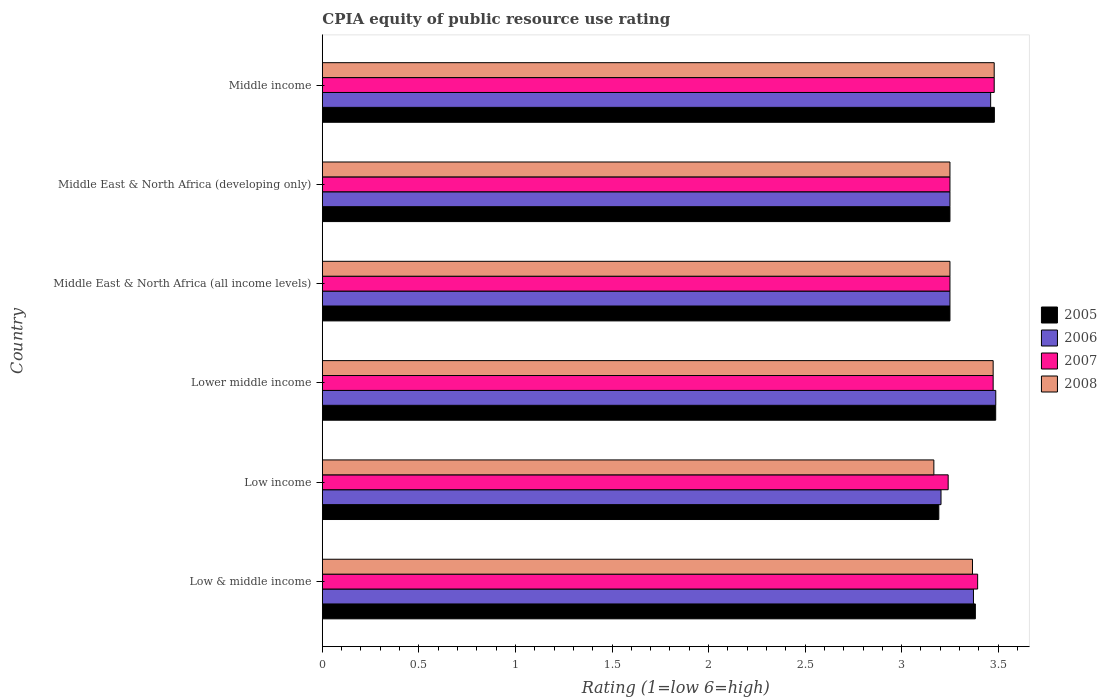How many groups of bars are there?
Give a very brief answer. 6. Are the number of bars on each tick of the Y-axis equal?
Ensure brevity in your answer.  Yes. What is the label of the 4th group of bars from the top?
Provide a short and direct response. Lower middle income. In how many cases, is the number of bars for a given country not equal to the number of legend labels?
Give a very brief answer. 0. Across all countries, what is the maximum CPIA rating in 2008?
Provide a succinct answer. 3.48. Across all countries, what is the minimum CPIA rating in 2006?
Make the answer very short. 3.2. In which country was the CPIA rating in 2006 maximum?
Your answer should be compact. Lower middle income. What is the total CPIA rating in 2008 in the graph?
Provide a short and direct response. 19.99. What is the difference between the CPIA rating in 2005 in Low & middle income and that in Middle East & North Africa (developing only)?
Keep it short and to the point. 0.13. What is the difference between the CPIA rating in 2005 in Middle income and the CPIA rating in 2007 in Low income?
Your answer should be very brief. 0.24. What is the average CPIA rating in 2008 per country?
Make the answer very short. 3.33. What is the difference between the CPIA rating in 2005 and CPIA rating in 2007 in Middle income?
Keep it short and to the point. 0. In how many countries, is the CPIA rating in 2006 greater than 3 ?
Make the answer very short. 6. What is the ratio of the CPIA rating in 2006 in Lower middle income to that in Middle East & North Africa (all income levels)?
Offer a very short reply. 1.07. What is the difference between the highest and the second highest CPIA rating in 2006?
Ensure brevity in your answer.  0.03. What is the difference between the highest and the lowest CPIA rating in 2007?
Your answer should be very brief. 0.24. In how many countries, is the CPIA rating in 2008 greater than the average CPIA rating in 2008 taken over all countries?
Make the answer very short. 3. Is it the case that in every country, the sum of the CPIA rating in 2008 and CPIA rating in 2005 is greater than the sum of CPIA rating in 2007 and CPIA rating in 2006?
Offer a very short reply. No. Is it the case that in every country, the sum of the CPIA rating in 2005 and CPIA rating in 2006 is greater than the CPIA rating in 2008?
Offer a terse response. Yes. Are all the bars in the graph horizontal?
Ensure brevity in your answer.  Yes. Does the graph contain grids?
Keep it short and to the point. No. Where does the legend appear in the graph?
Provide a short and direct response. Center right. How many legend labels are there?
Offer a terse response. 4. What is the title of the graph?
Offer a very short reply. CPIA equity of public resource use rating. What is the label or title of the Y-axis?
Your answer should be compact. Country. What is the Rating (1=low 6=high) of 2005 in Low & middle income?
Your answer should be compact. 3.38. What is the Rating (1=low 6=high) in 2006 in Low & middle income?
Keep it short and to the point. 3.37. What is the Rating (1=low 6=high) in 2007 in Low & middle income?
Ensure brevity in your answer.  3.39. What is the Rating (1=low 6=high) of 2008 in Low & middle income?
Offer a terse response. 3.37. What is the Rating (1=low 6=high) of 2005 in Low income?
Your answer should be compact. 3.19. What is the Rating (1=low 6=high) in 2006 in Low income?
Your answer should be very brief. 3.2. What is the Rating (1=low 6=high) in 2007 in Low income?
Ensure brevity in your answer.  3.24. What is the Rating (1=low 6=high) in 2008 in Low income?
Provide a short and direct response. 3.17. What is the Rating (1=low 6=high) in 2005 in Lower middle income?
Ensure brevity in your answer.  3.49. What is the Rating (1=low 6=high) of 2006 in Lower middle income?
Your answer should be compact. 3.49. What is the Rating (1=low 6=high) in 2007 in Lower middle income?
Offer a terse response. 3.47. What is the Rating (1=low 6=high) in 2008 in Lower middle income?
Offer a terse response. 3.47. What is the Rating (1=low 6=high) of 2005 in Middle East & North Africa (all income levels)?
Ensure brevity in your answer.  3.25. What is the Rating (1=low 6=high) in 2006 in Middle East & North Africa (developing only)?
Offer a terse response. 3.25. What is the Rating (1=low 6=high) of 2007 in Middle East & North Africa (developing only)?
Provide a succinct answer. 3.25. What is the Rating (1=low 6=high) in 2008 in Middle East & North Africa (developing only)?
Provide a succinct answer. 3.25. What is the Rating (1=low 6=high) in 2005 in Middle income?
Provide a succinct answer. 3.48. What is the Rating (1=low 6=high) in 2006 in Middle income?
Offer a terse response. 3.46. What is the Rating (1=low 6=high) in 2007 in Middle income?
Offer a terse response. 3.48. What is the Rating (1=low 6=high) in 2008 in Middle income?
Keep it short and to the point. 3.48. Across all countries, what is the maximum Rating (1=low 6=high) in 2005?
Your answer should be very brief. 3.49. Across all countries, what is the maximum Rating (1=low 6=high) in 2006?
Provide a succinct answer. 3.49. Across all countries, what is the maximum Rating (1=low 6=high) of 2007?
Give a very brief answer. 3.48. Across all countries, what is the maximum Rating (1=low 6=high) of 2008?
Offer a terse response. 3.48. Across all countries, what is the minimum Rating (1=low 6=high) of 2005?
Provide a short and direct response. 3.19. Across all countries, what is the minimum Rating (1=low 6=high) in 2006?
Provide a succinct answer. 3.2. Across all countries, what is the minimum Rating (1=low 6=high) in 2007?
Keep it short and to the point. 3.24. Across all countries, what is the minimum Rating (1=low 6=high) in 2008?
Keep it short and to the point. 3.17. What is the total Rating (1=low 6=high) of 2005 in the graph?
Offer a terse response. 20.04. What is the total Rating (1=low 6=high) of 2006 in the graph?
Provide a succinct answer. 20.02. What is the total Rating (1=low 6=high) in 2007 in the graph?
Your response must be concise. 20.09. What is the total Rating (1=low 6=high) of 2008 in the graph?
Offer a very short reply. 19.99. What is the difference between the Rating (1=low 6=high) of 2005 in Low & middle income and that in Low income?
Your answer should be compact. 0.19. What is the difference between the Rating (1=low 6=high) in 2006 in Low & middle income and that in Low income?
Provide a succinct answer. 0.17. What is the difference between the Rating (1=low 6=high) of 2007 in Low & middle income and that in Low income?
Ensure brevity in your answer.  0.15. What is the difference between the Rating (1=low 6=high) in 2005 in Low & middle income and that in Lower middle income?
Your response must be concise. -0.11. What is the difference between the Rating (1=low 6=high) of 2006 in Low & middle income and that in Lower middle income?
Offer a terse response. -0.12. What is the difference between the Rating (1=low 6=high) in 2007 in Low & middle income and that in Lower middle income?
Your response must be concise. -0.08. What is the difference between the Rating (1=low 6=high) in 2008 in Low & middle income and that in Lower middle income?
Give a very brief answer. -0.11. What is the difference between the Rating (1=low 6=high) of 2005 in Low & middle income and that in Middle East & North Africa (all income levels)?
Ensure brevity in your answer.  0.13. What is the difference between the Rating (1=low 6=high) in 2006 in Low & middle income and that in Middle East & North Africa (all income levels)?
Your response must be concise. 0.12. What is the difference between the Rating (1=low 6=high) of 2007 in Low & middle income and that in Middle East & North Africa (all income levels)?
Give a very brief answer. 0.14. What is the difference between the Rating (1=low 6=high) of 2008 in Low & middle income and that in Middle East & North Africa (all income levels)?
Provide a short and direct response. 0.12. What is the difference between the Rating (1=low 6=high) in 2005 in Low & middle income and that in Middle East & North Africa (developing only)?
Make the answer very short. 0.13. What is the difference between the Rating (1=low 6=high) of 2006 in Low & middle income and that in Middle East & North Africa (developing only)?
Ensure brevity in your answer.  0.12. What is the difference between the Rating (1=low 6=high) of 2007 in Low & middle income and that in Middle East & North Africa (developing only)?
Provide a short and direct response. 0.14. What is the difference between the Rating (1=low 6=high) in 2008 in Low & middle income and that in Middle East & North Africa (developing only)?
Your response must be concise. 0.12. What is the difference between the Rating (1=low 6=high) of 2005 in Low & middle income and that in Middle income?
Your answer should be very brief. -0.1. What is the difference between the Rating (1=low 6=high) of 2006 in Low & middle income and that in Middle income?
Make the answer very short. -0.09. What is the difference between the Rating (1=low 6=high) in 2007 in Low & middle income and that in Middle income?
Ensure brevity in your answer.  -0.09. What is the difference between the Rating (1=low 6=high) of 2008 in Low & middle income and that in Middle income?
Make the answer very short. -0.11. What is the difference between the Rating (1=low 6=high) in 2005 in Low income and that in Lower middle income?
Offer a terse response. -0.29. What is the difference between the Rating (1=low 6=high) in 2006 in Low income and that in Lower middle income?
Provide a succinct answer. -0.28. What is the difference between the Rating (1=low 6=high) in 2007 in Low income and that in Lower middle income?
Provide a succinct answer. -0.23. What is the difference between the Rating (1=low 6=high) of 2008 in Low income and that in Lower middle income?
Provide a short and direct response. -0.31. What is the difference between the Rating (1=low 6=high) in 2005 in Low income and that in Middle East & North Africa (all income levels)?
Your response must be concise. -0.06. What is the difference between the Rating (1=low 6=high) in 2006 in Low income and that in Middle East & North Africa (all income levels)?
Keep it short and to the point. -0.05. What is the difference between the Rating (1=low 6=high) of 2007 in Low income and that in Middle East & North Africa (all income levels)?
Your answer should be very brief. -0.01. What is the difference between the Rating (1=low 6=high) in 2008 in Low income and that in Middle East & North Africa (all income levels)?
Ensure brevity in your answer.  -0.08. What is the difference between the Rating (1=low 6=high) in 2005 in Low income and that in Middle East & North Africa (developing only)?
Provide a succinct answer. -0.06. What is the difference between the Rating (1=low 6=high) in 2006 in Low income and that in Middle East & North Africa (developing only)?
Give a very brief answer. -0.05. What is the difference between the Rating (1=low 6=high) in 2007 in Low income and that in Middle East & North Africa (developing only)?
Ensure brevity in your answer.  -0.01. What is the difference between the Rating (1=low 6=high) in 2008 in Low income and that in Middle East & North Africa (developing only)?
Make the answer very short. -0.08. What is the difference between the Rating (1=low 6=high) in 2005 in Low income and that in Middle income?
Your response must be concise. -0.29. What is the difference between the Rating (1=low 6=high) in 2006 in Low income and that in Middle income?
Keep it short and to the point. -0.26. What is the difference between the Rating (1=low 6=high) of 2007 in Low income and that in Middle income?
Provide a succinct answer. -0.24. What is the difference between the Rating (1=low 6=high) in 2008 in Low income and that in Middle income?
Provide a succinct answer. -0.31. What is the difference between the Rating (1=low 6=high) of 2005 in Lower middle income and that in Middle East & North Africa (all income levels)?
Provide a succinct answer. 0.24. What is the difference between the Rating (1=low 6=high) in 2006 in Lower middle income and that in Middle East & North Africa (all income levels)?
Your answer should be compact. 0.24. What is the difference between the Rating (1=low 6=high) of 2007 in Lower middle income and that in Middle East & North Africa (all income levels)?
Ensure brevity in your answer.  0.22. What is the difference between the Rating (1=low 6=high) of 2008 in Lower middle income and that in Middle East & North Africa (all income levels)?
Your answer should be compact. 0.22. What is the difference between the Rating (1=low 6=high) of 2005 in Lower middle income and that in Middle East & North Africa (developing only)?
Give a very brief answer. 0.24. What is the difference between the Rating (1=low 6=high) of 2006 in Lower middle income and that in Middle East & North Africa (developing only)?
Keep it short and to the point. 0.24. What is the difference between the Rating (1=low 6=high) in 2007 in Lower middle income and that in Middle East & North Africa (developing only)?
Give a very brief answer. 0.22. What is the difference between the Rating (1=low 6=high) of 2008 in Lower middle income and that in Middle East & North Africa (developing only)?
Offer a terse response. 0.22. What is the difference between the Rating (1=low 6=high) of 2005 in Lower middle income and that in Middle income?
Provide a short and direct response. 0.01. What is the difference between the Rating (1=low 6=high) of 2006 in Lower middle income and that in Middle income?
Give a very brief answer. 0.03. What is the difference between the Rating (1=low 6=high) in 2007 in Lower middle income and that in Middle income?
Ensure brevity in your answer.  -0.01. What is the difference between the Rating (1=low 6=high) of 2008 in Lower middle income and that in Middle income?
Offer a terse response. -0.01. What is the difference between the Rating (1=low 6=high) of 2005 in Middle East & North Africa (all income levels) and that in Middle East & North Africa (developing only)?
Your answer should be compact. 0. What is the difference between the Rating (1=low 6=high) in 2008 in Middle East & North Africa (all income levels) and that in Middle East & North Africa (developing only)?
Your response must be concise. 0. What is the difference between the Rating (1=low 6=high) in 2005 in Middle East & North Africa (all income levels) and that in Middle income?
Ensure brevity in your answer.  -0.23. What is the difference between the Rating (1=low 6=high) in 2006 in Middle East & North Africa (all income levels) and that in Middle income?
Keep it short and to the point. -0.21. What is the difference between the Rating (1=low 6=high) of 2007 in Middle East & North Africa (all income levels) and that in Middle income?
Provide a succinct answer. -0.23. What is the difference between the Rating (1=low 6=high) of 2008 in Middle East & North Africa (all income levels) and that in Middle income?
Your response must be concise. -0.23. What is the difference between the Rating (1=low 6=high) of 2005 in Middle East & North Africa (developing only) and that in Middle income?
Make the answer very short. -0.23. What is the difference between the Rating (1=low 6=high) in 2006 in Middle East & North Africa (developing only) and that in Middle income?
Provide a short and direct response. -0.21. What is the difference between the Rating (1=low 6=high) of 2007 in Middle East & North Africa (developing only) and that in Middle income?
Your answer should be compact. -0.23. What is the difference between the Rating (1=low 6=high) of 2008 in Middle East & North Africa (developing only) and that in Middle income?
Provide a succinct answer. -0.23. What is the difference between the Rating (1=low 6=high) of 2005 in Low & middle income and the Rating (1=low 6=high) of 2006 in Low income?
Make the answer very short. 0.18. What is the difference between the Rating (1=low 6=high) of 2005 in Low & middle income and the Rating (1=low 6=high) of 2007 in Low income?
Ensure brevity in your answer.  0.14. What is the difference between the Rating (1=low 6=high) of 2005 in Low & middle income and the Rating (1=low 6=high) of 2008 in Low income?
Provide a succinct answer. 0.21. What is the difference between the Rating (1=low 6=high) in 2006 in Low & middle income and the Rating (1=low 6=high) in 2007 in Low income?
Provide a short and direct response. 0.13. What is the difference between the Rating (1=low 6=high) in 2006 in Low & middle income and the Rating (1=low 6=high) in 2008 in Low income?
Provide a succinct answer. 0.21. What is the difference between the Rating (1=low 6=high) in 2007 in Low & middle income and the Rating (1=low 6=high) in 2008 in Low income?
Provide a short and direct response. 0.23. What is the difference between the Rating (1=low 6=high) in 2005 in Low & middle income and the Rating (1=low 6=high) in 2006 in Lower middle income?
Your response must be concise. -0.11. What is the difference between the Rating (1=low 6=high) in 2005 in Low & middle income and the Rating (1=low 6=high) in 2007 in Lower middle income?
Ensure brevity in your answer.  -0.09. What is the difference between the Rating (1=low 6=high) of 2005 in Low & middle income and the Rating (1=low 6=high) of 2008 in Lower middle income?
Provide a short and direct response. -0.09. What is the difference between the Rating (1=low 6=high) in 2006 in Low & middle income and the Rating (1=low 6=high) in 2007 in Lower middle income?
Your answer should be compact. -0.1. What is the difference between the Rating (1=low 6=high) in 2006 in Low & middle income and the Rating (1=low 6=high) in 2008 in Lower middle income?
Your answer should be compact. -0.1. What is the difference between the Rating (1=low 6=high) in 2007 in Low & middle income and the Rating (1=low 6=high) in 2008 in Lower middle income?
Keep it short and to the point. -0.08. What is the difference between the Rating (1=low 6=high) in 2005 in Low & middle income and the Rating (1=low 6=high) in 2006 in Middle East & North Africa (all income levels)?
Offer a terse response. 0.13. What is the difference between the Rating (1=low 6=high) of 2005 in Low & middle income and the Rating (1=low 6=high) of 2007 in Middle East & North Africa (all income levels)?
Ensure brevity in your answer.  0.13. What is the difference between the Rating (1=low 6=high) in 2005 in Low & middle income and the Rating (1=low 6=high) in 2008 in Middle East & North Africa (all income levels)?
Offer a very short reply. 0.13. What is the difference between the Rating (1=low 6=high) in 2006 in Low & middle income and the Rating (1=low 6=high) in 2007 in Middle East & North Africa (all income levels)?
Your response must be concise. 0.12. What is the difference between the Rating (1=low 6=high) in 2006 in Low & middle income and the Rating (1=low 6=high) in 2008 in Middle East & North Africa (all income levels)?
Offer a terse response. 0.12. What is the difference between the Rating (1=low 6=high) in 2007 in Low & middle income and the Rating (1=low 6=high) in 2008 in Middle East & North Africa (all income levels)?
Give a very brief answer. 0.14. What is the difference between the Rating (1=low 6=high) of 2005 in Low & middle income and the Rating (1=low 6=high) of 2006 in Middle East & North Africa (developing only)?
Ensure brevity in your answer.  0.13. What is the difference between the Rating (1=low 6=high) of 2005 in Low & middle income and the Rating (1=low 6=high) of 2007 in Middle East & North Africa (developing only)?
Your response must be concise. 0.13. What is the difference between the Rating (1=low 6=high) in 2005 in Low & middle income and the Rating (1=low 6=high) in 2008 in Middle East & North Africa (developing only)?
Offer a terse response. 0.13. What is the difference between the Rating (1=low 6=high) of 2006 in Low & middle income and the Rating (1=low 6=high) of 2007 in Middle East & North Africa (developing only)?
Your answer should be compact. 0.12. What is the difference between the Rating (1=low 6=high) in 2006 in Low & middle income and the Rating (1=low 6=high) in 2008 in Middle East & North Africa (developing only)?
Your answer should be very brief. 0.12. What is the difference between the Rating (1=low 6=high) of 2007 in Low & middle income and the Rating (1=low 6=high) of 2008 in Middle East & North Africa (developing only)?
Provide a short and direct response. 0.14. What is the difference between the Rating (1=low 6=high) of 2005 in Low & middle income and the Rating (1=low 6=high) of 2006 in Middle income?
Offer a very short reply. -0.08. What is the difference between the Rating (1=low 6=high) in 2005 in Low & middle income and the Rating (1=low 6=high) in 2007 in Middle income?
Keep it short and to the point. -0.1. What is the difference between the Rating (1=low 6=high) in 2005 in Low & middle income and the Rating (1=low 6=high) in 2008 in Middle income?
Offer a very short reply. -0.1. What is the difference between the Rating (1=low 6=high) in 2006 in Low & middle income and the Rating (1=low 6=high) in 2007 in Middle income?
Ensure brevity in your answer.  -0.11. What is the difference between the Rating (1=low 6=high) in 2006 in Low & middle income and the Rating (1=low 6=high) in 2008 in Middle income?
Give a very brief answer. -0.11. What is the difference between the Rating (1=low 6=high) of 2007 in Low & middle income and the Rating (1=low 6=high) of 2008 in Middle income?
Ensure brevity in your answer.  -0.09. What is the difference between the Rating (1=low 6=high) in 2005 in Low income and the Rating (1=low 6=high) in 2006 in Lower middle income?
Provide a succinct answer. -0.29. What is the difference between the Rating (1=low 6=high) in 2005 in Low income and the Rating (1=low 6=high) in 2007 in Lower middle income?
Provide a short and direct response. -0.28. What is the difference between the Rating (1=low 6=high) in 2005 in Low income and the Rating (1=low 6=high) in 2008 in Lower middle income?
Provide a succinct answer. -0.28. What is the difference between the Rating (1=low 6=high) in 2006 in Low income and the Rating (1=low 6=high) in 2007 in Lower middle income?
Provide a succinct answer. -0.27. What is the difference between the Rating (1=low 6=high) of 2006 in Low income and the Rating (1=low 6=high) of 2008 in Lower middle income?
Give a very brief answer. -0.27. What is the difference between the Rating (1=low 6=high) in 2007 in Low income and the Rating (1=low 6=high) in 2008 in Lower middle income?
Provide a succinct answer. -0.23. What is the difference between the Rating (1=low 6=high) of 2005 in Low income and the Rating (1=low 6=high) of 2006 in Middle East & North Africa (all income levels)?
Ensure brevity in your answer.  -0.06. What is the difference between the Rating (1=low 6=high) in 2005 in Low income and the Rating (1=low 6=high) in 2007 in Middle East & North Africa (all income levels)?
Offer a very short reply. -0.06. What is the difference between the Rating (1=low 6=high) in 2005 in Low income and the Rating (1=low 6=high) in 2008 in Middle East & North Africa (all income levels)?
Give a very brief answer. -0.06. What is the difference between the Rating (1=low 6=high) in 2006 in Low income and the Rating (1=low 6=high) in 2007 in Middle East & North Africa (all income levels)?
Ensure brevity in your answer.  -0.05. What is the difference between the Rating (1=low 6=high) of 2006 in Low income and the Rating (1=low 6=high) of 2008 in Middle East & North Africa (all income levels)?
Provide a succinct answer. -0.05. What is the difference between the Rating (1=low 6=high) in 2007 in Low income and the Rating (1=low 6=high) in 2008 in Middle East & North Africa (all income levels)?
Your answer should be compact. -0.01. What is the difference between the Rating (1=low 6=high) of 2005 in Low income and the Rating (1=low 6=high) of 2006 in Middle East & North Africa (developing only)?
Provide a short and direct response. -0.06. What is the difference between the Rating (1=low 6=high) in 2005 in Low income and the Rating (1=low 6=high) in 2007 in Middle East & North Africa (developing only)?
Provide a succinct answer. -0.06. What is the difference between the Rating (1=low 6=high) of 2005 in Low income and the Rating (1=low 6=high) of 2008 in Middle East & North Africa (developing only)?
Offer a terse response. -0.06. What is the difference between the Rating (1=low 6=high) of 2006 in Low income and the Rating (1=low 6=high) of 2007 in Middle East & North Africa (developing only)?
Your answer should be compact. -0.05. What is the difference between the Rating (1=low 6=high) of 2006 in Low income and the Rating (1=low 6=high) of 2008 in Middle East & North Africa (developing only)?
Give a very brief answer. -0.05. What is the difference between the Rating (1=low 6=high) of 2007 in Low income and the Rating (1=low 6=high) of 2008 in Middle East & North Africa (developing only)?
Make the answer very short. -0.01. What is the difference between the Rating (1=low 6=high) of 2005 in Low income and the Rating (1=low 6=high) of 2006 in Middle income?
Provide a succinct answer. -0.27. What is the difference between the Rating (1=low 6=high) of 2005 in Low income and the Rating (1=low 6=high) of 2007 in Middle income?
Your response must be concise. -0.29. What is the difference between the Rating (1=low 6=high) in 2005 in Low income and the Rating (1=low 6=high) in 2008 in Middle income?
Your response must be concise. -0.29. What is the difference between the Rating (1=low 6=high) in 2006 in Low income and the Rating (1=low 6=high) in 2007 in Middle income?
Ensure brevity in your answer.  -0.28. What is the difference between the Rating (1=low 6=high) of 2006 in Low income and the Rating (1=low 6=high) of 2008 in Middle income?
Your answer should be very brief. -0.28. What is the difference between the Rating (1=low 6=high) in 2007 in Low income and the Rating (1=low 6=high) in 2008 in Middle income?
Keep it short and to the point. -0.24. What is the difference between the Rating (1=low 6=high) of 2005 in Lower middle income and the Rating (1=low 6=high) of 2006 in Middle East & North Africa (all income levels)?
Ensure brevity in your answer.  0.24. What is the difference between the Rating (1=low 6=high) of 2005 in Lower middle income and the Rating (1=low 6=high) of 2007 in Middle East & North Africa (all income levels)?
Ensure brevity in your answer.  0.24. What is the difference between the Rating (1=low 6=high) in 2005 in Lower middle income and the Rating (1=low 6=high) in 2008 in Middle East & North Africa (all income levels)?
Make the answer very short. 0.24. What is the difference between the Rating (1=low 6=high) in 2006 in Lower middle income and the Rating (1=low 6=high) in 2007 in Middle East & North Africa (all income levels)?
Keep it short and to the point. 0.24. What is the difference between the Rating (1=low 6=high) of 2006 in Lower middle income and the Rating (1=low 6=high) of 2008 in Middle East & North Africa (all income levels)?
Your response must be concise. 0.24. What is the difference between the Rating (1=low 6=high) in 2007 in Lower middle income and the Rating (1=low 6=high) in 2008 in Middle East & North Africa (all income levels)?
Offer a terse response. 0.22. What is the difference between the Rating (1=low 6=high) of 2005 in Lower middle income and the Rating (1=low 6=high) of 2006 in Middle East & North Africa (developing only)?
Ensure brevity in your answer.  0.24. What is the difference between the Rating (1=low 6=high) in 2005 in Lower middle income and the Rating (1=low 6=high) in 2007 in Middle East & North Africa (developing only)?
Your answer should be compact. 0.24. What is the difference between the Rating (1=low 6=high) in 2005 in Lower middle income and the Rating (1=low 6=high) in 2008 in Middle East & North Africa (developing only)?
Ensure brevity in your answer.  0.24. What is the difference between the Rating (1=low 6=high) in 2006 in Lower middle income and the Rating (1=low 6=high) in 2007 in Middle East & North Africa (developing only)?
Ensure brevity in your answer.  0.24. What is the difference between the Rating (1=low 6=high) in 2006 in Lower middle income and the Rating (1=low 6=high) in 2008 in Middle East & North Africa (developing only)?
Your response must be concise. 0.24. What is the difference between the Rating (1=low 6=high) in 2007 in Lower middle income and the Rating (1=low 6=high) in 2008 in Middle East & North Africa (developing only)?
Give a very brief answer. 0.22. What is the difference between the Rating (1=low 6=high) of 2005 in Lower middle income and the Rating (1=low 6=high) of 2006 in Middle income?
Offer a very short reply. 0.03. What is the difference between the Rating (1=low 6=high) of 2005 in Lower middle income and the Rating (1=low 6=high) of 2007 in Middle income?
Your answer should be compact. 0.01. What is the difference between the Rating (1=low 6=high) of 2005 in Lower middle income and the Rating (1=low 6=high) of 2008 in Middle income?
Offer a very short reply. 0.01. What is the difference between the Rating (1=low 6=high) in 2006 in Lower middle income and the Rating (1=low 6=high) in 2007 in Middle income?
Provide a succinct answer. 0.01. What is the difference between the Rating (1=low 6=high) of 2006 in Lower middle income and the Rating (1=low 6=high) of 2008 in Middle income?
Your answer should be very brief. 0.01. What is the difference between the Rating (1=low 6=high) of 2007 in Lower middle income and the Rating (1=low 6=high) of 2008 in Middle income?
Ensure brevity in your answer.  -0.01. What is the difference between the Rating (1=low 6=high) of 2005 in Middle East & North Africa (all income levels) and the Rating (1=low 6=high) of 2006 in Middle East & North Africa (developing only)?
Make the answer very short. 0. What is the difference between the Rating (1=low 6=high) in 2005 in Middle East & North Africa (all income levels) and the Rating (1=low 6=high) in 2007 in Middle East & North Africa (developing only)?
Provide a short and direct response. 0. What is the difference between the Rating (1=low 6=high) of 2005 in Middle East & North Africa (all income levels) and the Rating (1=low 6=high) of 2008 in Middle East & North Africa (developing only)?
Keep it short and to the point. 0. What is the difference between the Rating (1=low 6=high) in 2006 in Middle East & North Africa (all income levels) and the Rating (1=low 6=high) in 2007 in Middle East & North Africa (developing only)?
Offer a terse response. 0. What is the difference between the Rating (1=low 6=high) of 2007 in Middle East & North Africa (all income levels) and the Rating (1=low 6=high) of 2008 in Middle East & North Africa (developing only)?
Keep it short and to the point. 0. What is the difference between the Rating (1=low 6=high) of 2005 in Middle East & North Africa (all income levels) and the Rating (1=low 6=high) of 2006 in Middle income?
Keep it short and to the point. -0.21. What is the difference between the Rating (1=low 6=high) of 2005 in Middle East & North Africa (all income levels) and the Rating (1=low 6=high) of 2007 in Middle income?
Your answer should be compact. -0.23. What is the difference between the Rating (1=low 6=high) in 2005 in Middle East & North Africa (all income levels) and the Rating (1=low 6=high) in 2008 in Middle income?
Your answer should be compact. -0.23. What is the difference between the Rating (1=low 6=high) of 2006 in Middle East & North Africa (all income levels) and the Rating (1=low 6=high) of 2007 in Middle income?
Keep it short and to the point. -0.23. What is the difference between the Rating (1=low 6=high) of 2006 in Middle East & North Africa (all income levels) and the Rating (1=low 6=high) of 2008 in Middle income?
Offer a very short reply. -0.23. What is the difference between the Rating (1=low 6=high) of 2007 in Middle East & North Africa (all income levels) and the Rating (1=low 6=high) of 2008 in Middle income?
Your response must be concise. -0.23. What is the difference between the Rating (1=low 6=high) of 2005 in Middle East & North Africa (developing only) and the Rating (1=low 6=high) of 2006 in Middle income?
Give a very brief answer. -0.21. What is the difference between the Rating (1=low 6=high) in 2005 in Middle East & North Africa (developing only) and the Rating (1=low 6=high) in 2007 in Middle income?
Keep it short and to the point. -0.23. What is the difference between the Rating (1=low 6=high) in 2005 in Middle East & North Africa (developing only) and the Rating (1=low 6=high) in 2008 in Middle income?
Ensure brevity in your answer.  -0.23. What is the difference between the Rating (1=low 6=high) of 2006 in Middle East & North Africa (developing only) and the Rating (1=low 6=high) of 2007 in Middle income?
Your response must be concise. -0.23. What is the difference between the Rating (1=low 6=high) of 2006 in Middle East & North Africa (developing only) and the Rating (1=low 6=high) of 2008 in Middle income?
Your answer should be compact. -0.23. What is the difference between the Rating (1=low 6=high) of 2007 in Middle East & North Africa (developing only) and the Rating (1=low 6=high) of 2008 in Middle income?
Give a very brief answer. -0.23. What is the average Rating (1=low 6=high) in 2005 per country?
Offer a terse response. 3.34. What is the average Rating (1=low 6=high) in 2006 per country?
Provide a succinct answer. 3.34. What is the average Rating (1=low 6=high) in 2007 per country?
Offer a terse response. 3.35. What is the average Rating (1=low 6=high) of 2008 per country?
Provide a short and direct response. 3.33. What is the difference between the Rating (1=low 6=high) in 2005 and Rating (1=low 6=high) in 2006 in Low & middle income?
Your answer should be compact. 0.01. What is the difference between the Rating (1=low 6=high) of 2005 and Rating (1=low 6=high) of 2007 in Low & middle income?
Ensure brevity in your answer.  -0.01. What is the difference between the Rating (1=low 6=high) in 2005 and Rating (1=low 6=high) in 2008 in Low & middle income?
Your response must be concise. 0.01. What is the difference between the Rating (1=low 6=high) of 2006 and Rating (1=low 6=high) of 2007 in Low & middle income?
Your answer should be compact. -0.02. What is the difference between the Rating (1=low 6=high) of 2006 and Rating (1=low 6=high) of 2008 in Low & middle income?
Your answer should be very brief. 0.01. What is the difference between the Rating (1=low 6=high) in 2007 and Rating (1=low 6=high) in 2008 in Low & middle income?
Your answer should be very brief. 0.03. What is the difference between the Rating (1=low 6=high) of 2005 and Rating (1=low 6=high) of 2006 in Low income?
Give a very brief answer. -0.01. What is the difference between the Rating (1=low 6=high) of 2005 and Rating (1=low 6=high) of 2007 in Low income?
Make the answer very short. -0.05. What is the difference between the Rating (1=low 6=high) in 2005 and Rating (1=low 6=high) in 2008 in Low income?
Provide a short and direct response. 0.03. What is the difference between the Rating (1=low 6=high) of 2006 and Rating (1=low 6=high) of 2007 in Low income?
Offer a very short reply. -0.04. What is the difference between the Rating (1=low 6=high) of 2006 and Rating (1=low 6=high) of 2008 in Low income?
Offer a very short reply. 0.04. What is the difference between the Rating (1=low 6=high) in 2007 and Rating (1=low 6=high) in 2008 in Low income?
Make the answer very short. 0.07. What is the difference between the Rating (1=low 6=high) in 2005 and Rating (1=low 6=high) in 2006 in Lower middle income?
Provide a succinct answer. -0. What is the difference between the Rating (1=low 6=high) in 2005 and Rating (1=low 6=high) in 2007 in Lower middle income?
Make the answer very short. 0.01. What is the difference between the Rating (1=low 6=high) of 2005 and Rating (1=low 6=high) of 2008 in Lower middle income?
Keep it short and to the point. 0.01. What is the difference between the Rating (1=low 6=high) of 2006 and Rating (1=low 6=high) of 2007 in Lower middle income?
Your answer should be very brief. 0.01. What is the difference between the Rating (1=low 6=high) of 2006 and Rating (1=low 6=high) of 2008 in Lower middle income?
Your response must be concise. 0.01. What is the difference between the Rating (1=low 6=high) of 2005 and Rating (1=low 6=high) of 2006 in Middle East & North Africa (all income levels)?
Offer a very short reply. 0. What is the difference between the Rating (1=low 6=high) in 2005 and Rating (1=low 6=high) in 2007 in Middle East & North Africa (all income levels)?
Your answer should be very brief. 0. What is the difference between the Rating (1=low 6=high) in 2007 and Rating (1=low 6=high) in 2008 in Middle East & North Africa (all income levels)?
Provide a succinct answer. 0. What is the difference between the Rating (1=low 6=high) in 2005 and Rating (1=low 6=high) in 2007 in Middle East & North Africa (developing only)?
Your response must be concise. 0. What is the difference between the Rating (1=low 6=high) in 2007 and Rating (1=low 6=high) in 2008 in Middle East & North Africa (developing only)?
Make the answer very short. 0. What is the difference between the Rating (1=low 6=high) in 2005 and Rating (1=low 6=high) in 2006 in Middle income?
Your answer should be very brief. 0.02. What is the difference between the Rating (1=low 6=high) in 2005 and Rating (1=low 6=high) in 2007 in Middle income?
Make the answer very short. 0. What is the difference between the Rating (1=low 6=high) in 2005 and Rating (1=low 6=high) in 2008 in Middle income?
Keep it short and to the point. 0. What is the difference between the Rating (1=low 6=high) of 2006 and Rating (1=low 6=high) of 2007 in Middle income?
Ensure brevity in your answer.  -0.02. What is the difference between the Rating (1=low 6=high) of 2006 and Rating (1=low 6=high) of 2008 in Middle income?
Your answer should be very brief. -0.02. What is the difference between the Rating (1=low 6=high) of 2007 and Rating (1=low 6=high) of 2008 in Middle income?
Make the answer very short. 0. What is the ratio of the Rating (1=low 6=high) of 2005 in Low & middle income to that in Low income?
Make the answer very short. 1.06. What is the ratio of the Rating (1=low 6=high) of 2006 in Low & middle income to that in Low income?
Make the answer very short. 1.05. What is the ratio of the Rating (1=low 6=high) of 2007 in Low & middle income to that in Low income?
Give a very brief answer. 1.05. What is the ratio of the Rating (1=low 6=high) in 2008 in Low & middle income to that in Low income?
Keep it short and to the point. 1.06. What is the ratio of the Rating (1=low 6=high) in 2005 in Low & middle income to that in Lower middle income?
Provide a succinct answer. 0.97. What is the ratio of the Rating (1=low 6=high) of 2006 in Low & middle income to that in Lower middle income?
Provide a short and direct response. 0.97. What is the ratio of the Rating (1=low 6=high) in 2007 in Low & middle income to that in Lower middle income?
Provide a short and direct response. 0.98. What is the ratio of the Rating (1=low 6=high) of 2008 in Low & middle income to that in Lower middle income?
Make the answer very short. 0.97. What is the ratio of the Rating (1=low 6=high) of 2005 in Low & middle income to that in Middle East & North Africa (all income levels)?
Your answer should be very brief. 1.04. What is the ratio of the Rating (1=low 6=high) in 2006 in Low & middle income to that in Middle East & North Africa (all income levels)?
Your response must be concise. 1.04. What is the ratio of the Rating (1=low 6=high) in 2007 in Low & middle income to that in Middle East & North Africa (all income levels)?
Provide a succinct answer. 1.04. What is the ratio of the Rating (1=low 6=high) of 2008 in Low & middle income to that in Middle East & North Africa (all income levels)?
Your answer should be compact. 1.04. What is the ratio of the Rating (1=low 6=high) of 2005 in Low & middle income to that in Middle East & North Africa (developing only)?
Ensure brevity in your answer.  1.04. What is the ratio of the Rating (1=low 6=high) of 2006 in Low & middle income to that in Middle East & North Africa (developing only)?
Your response must be concise. 1.04. What is the ratio of the Rating (1=low 6=high) of 2007 in Low & middle income to that in Middle East & North Africa (developing only)?
Ensure brevity in your answer.  1.04. What is the ratio of the Rating (1=low 6=high) of 2008 in Low & middle income to that in Middle East & North Africa (developing only)?
Your response must be concise. 1.04. What is the ratio of the Rating (1=low 6=high) of 2005 in Low & middle income to that in Middle income?
Provide a short and direct response. 0.97. What is the ratio of the Rating (1=low 6=high) of 2006 in Low & middle income to that in Middle income?
Keep it short and to the point. 0.97. What is the ratio of the Rating (1=low 6=high) of 2007 in Low & middle income to that in Middle income?
Your answer should be very brief. 0.98. What is the ratio of the Rating (1=low 6=high) in 2005 in Low income to that in Lower middle income?
Provide a short and direct response. 0.92. What is the ratio of the Rating (1=low 6=high) of 2006 in Low income to that in Lower middle income?
Your response must be concise. 0.92. What is the ratio of the Rating (1=low 6=high) in 2007 in Low income to that in Lower middle income?
Your answer should be compact. 0.93. What is the ratio of the Rating (1=low 6=high) in 2008 in Low income to that in Lower middle income?
Your answer should be compact. 0.91. What is the ratio of the Rating (1=low 6=high) of 2005 in Low income to that in Middle East & North Africa (all income levels)?
Offer a very short reply. 0.98. What is the ratio of the Rating (1=low 6=high) of 2006 in Low income to that in Middle East & North Africa (all income levels)?
Your response must be concise. 0.99. What is the ratio of the Rating (1=low 6=high) in 2007 in Low income to that in Middle East & North Africa (all income levels)?
Provide a succinct answer. 1. What is the ratio of the Rating (1=low 6=high) in 2008 in Low income to that in Middle East & North Africa (all income levels)?
Your answer should be compact. 0.97. What is the ratio of the Rating (1=low 6=high) of 2005 in Low income to that in Middle East & North Africa (developing only)?
Your answer should be very brief. 0.98. What is the ratio of the Rating (1=low 6=high) of 2006 in Low income to that in Middle East & North Africa (developing only)?
Give a very brief answer. 0.99. What is the ratio of the Rating (1=low 6=high) of 2008 in Low income to that in Middle East & North Africa (developing only)?
Provide a short and direct response. 0.97. What is the ratio of the Rating (1=low 6=high) in 2005 in Low income to that in Middle income?
Offer a very short reply. 0.92. What is the ratio of the Rating (1=low 6=high) of 2006 in Low income to that in Middle income?
Ensure brevity in your answer.  0.93. What is the ratio of the Rating (1=low 6=high) in 2007 in Low income to that in Middle income?
Provide a succinct answer. 0.93. What is the ratio of the Rating (1=low 6=high) of 2008 in Low income to that in Middle income?
Provide a short and direct response. 0.91. What is the ratio of the Rating (1=low 6=high) of 2005 in Lower middle income to that in Middle East & North Africa (all income levels)?
Offer a terse response. 1.07. What is the ratio of the Rating (1=low 6=high) of 2006 in Lower middle income to that in Middle East & North Africa (all income levels)?
Make the answer very short. 1.07. What is the ratio of the Rating (1=low 6=high) in 2007 in Lower middle income to that in Middle East & North Africa (all income levels)?
Provide a succinct answer. 1.07. What is the ratio of the Rating (1=low 6=high) of 2008 in Lower middle income to that in Middle East & North Africa (all income levels)?
Give a very brief answer. 1.07. What is the ratio of the Rating (1=low 6=high) of 2005 in Lower middle income to that in Middle East & North Africa (developing only)?
Give a very brief answer. 1.07. What is the ratio of the Rating (1=low 6=high) in 2006 in Lower middle income to that in Middle East & North Africa (developing only)?
Your response must be concise. 1.07. What is the ratio of the Rating (1=low 6=high) in 2007 in Lower middle income to that in Middle East & North Africa (developing only)?
Keep it short and to the point. 1.07. What is the ratio of the Rating (1=low 6=high) in 2008 in Lower middle income to that in Middle East & North Africa (developing only)?
Your response must be concise. 1.07. What is the ratio of the Rating (1=low 6=high) in 2006 in Lower middle income to that in Middle income?
Give a very brief answer. 1.01. What is the ratio of the Rating (1=low 6=high) in 2008 in Lower middle income to that in Middle income?
Your answer should be compact. 1. What is the ratio of the Rating (1=low 6=high) in 2005 in Middle East & North Africa (all income levels) to that in Middle East & North Africa (developing only)?
Offer a very short reply. 1. What is the ratio of the Rating (1=low 6=high) in 2006 in Middle East & North Africa (all income levels) to that in Middle East & North Africa (developing only)?
Your response must be concise. 1. What is the ratio of the Rating (1=low 6=high) of 2005 in Middle East & North Africa (all income levels) to that in Middle income?
Make the answer very short. 0.93. What is the ratio of the Rating (1=low 6=high) in 2006 in Middle East & North Africa (all income levels) to that in Middle income?
Provide a short and direct response. 0.94. What is the ratio of the Rating (1=low 6=high) in 2007 in Middle East & North Africa (all income levels) to that in Middle income?
Offer a terse response. 0.93. What is the ratio of the Rating (1=low 6=high) of 2008 in Middle East & North Africa (all income levels) to that in Middle income?
Your response must be concise. 0.93. What is the ratio of the Rating (1=low 6=high) in 2005 in Middle East & North Africa (developing only) to that in Middle income?
Offer a very short reply. 0.93. What is the ratio of the Rating (1=low 6=high) of 2006 in Middle East & North Africa (developing only) to that in Middle income?
Give a very brief answer. 0.94. What is the ratio of the Rating (1=low 6=high) of 2007 in Middle East & North Africa (developing only) to that in Middle income?
Your response must be concise. 0.93. What is the ratio of the Rating (1=low 6=high) in 2008 in Middle East & North Africa (developing only) to that in Middle income?
Your answer should be compact. 0.93. What is the difference between the highest and the second highest Rating (1=low 6=high) in 2005?
Provide a short and direct response. 0.01. What is the difference between the highest and the second highest Rating (1=low 6=high) of 2006?
Your answer should be compact. 0.03. What is the difference between the highest and the second highest Rating (1=low 6=high) of 2007?
Provide a short and direct response. 0.01. What is the difference between the highest and the second highest Rating (1=low 6=high) of 2008?
Keep it short and to the point. 0.01. What is the difference between the highest and the lowest Rating (1=low 6=high) in 2005?
Provide a succinct answer. 0.29. What is the difference between the highest and the lowest Rating (1=low 6=high) in 2006?
Your answer should be compact. 0.28. What is the difference between the highest and the lowest Rating (1=low 6=high) in 2007?
Your answer should be very brief. 0.24. What is the difference between the highest and the lowest Rating (1=low 6=high) in 2008?
Offer a terse response. 0.31. 